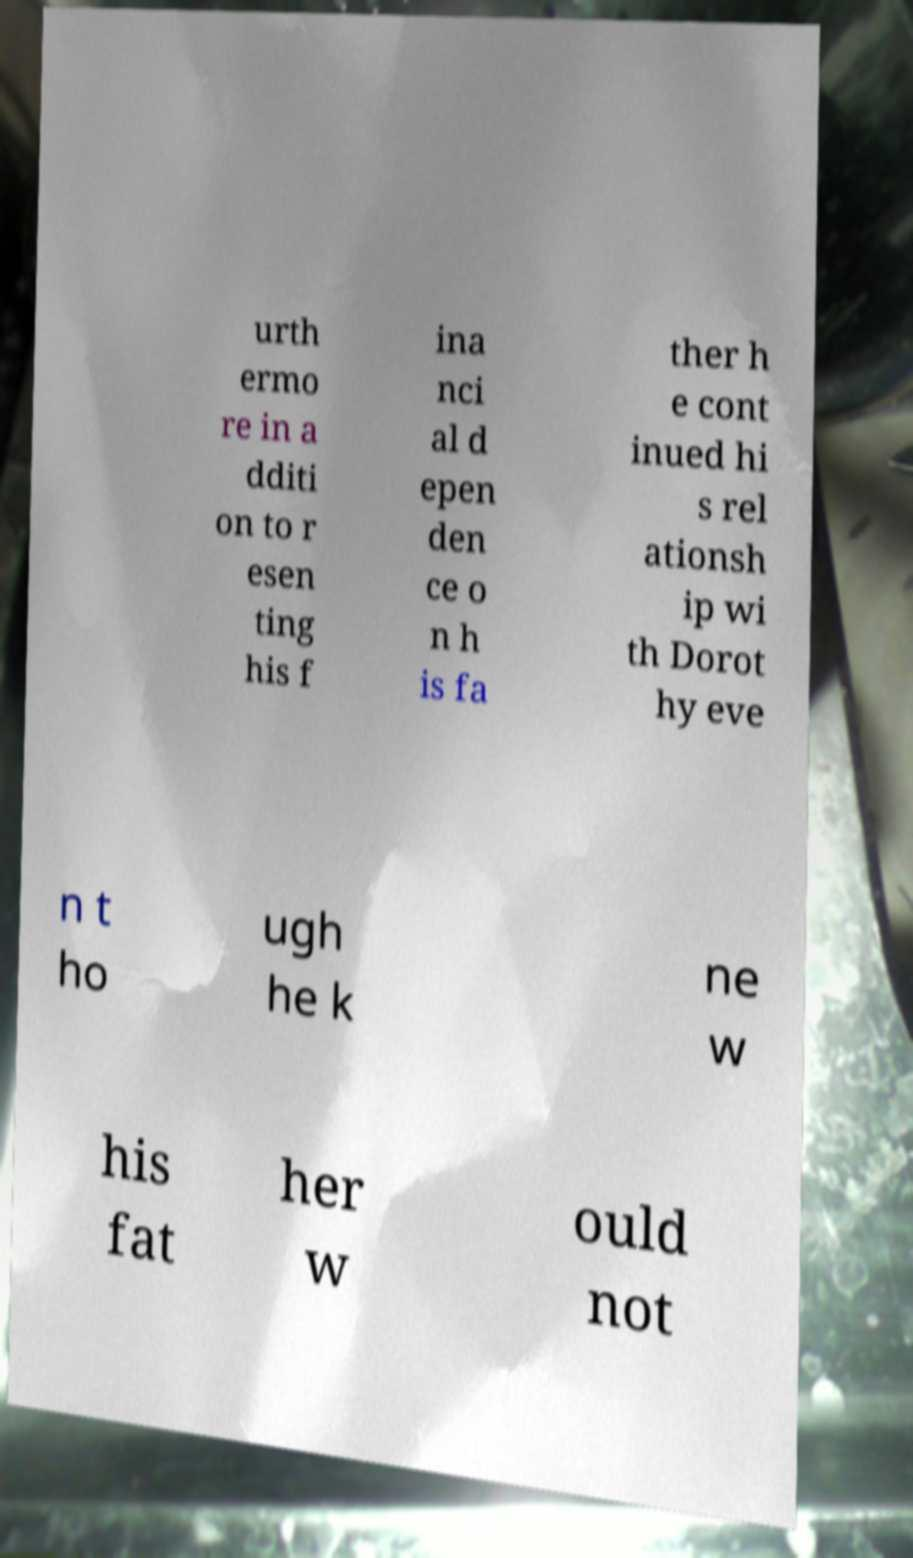Please read and relay the text visible in this image. What does it say? urth ermo re in a dditi on to r esen ting his f ina nci al d epen den ce o n h is fa ther h e cont inued hi s rel ationsh ip wi th Dorot hy eve n t ho ugh he k ne w his fat her w ould not 